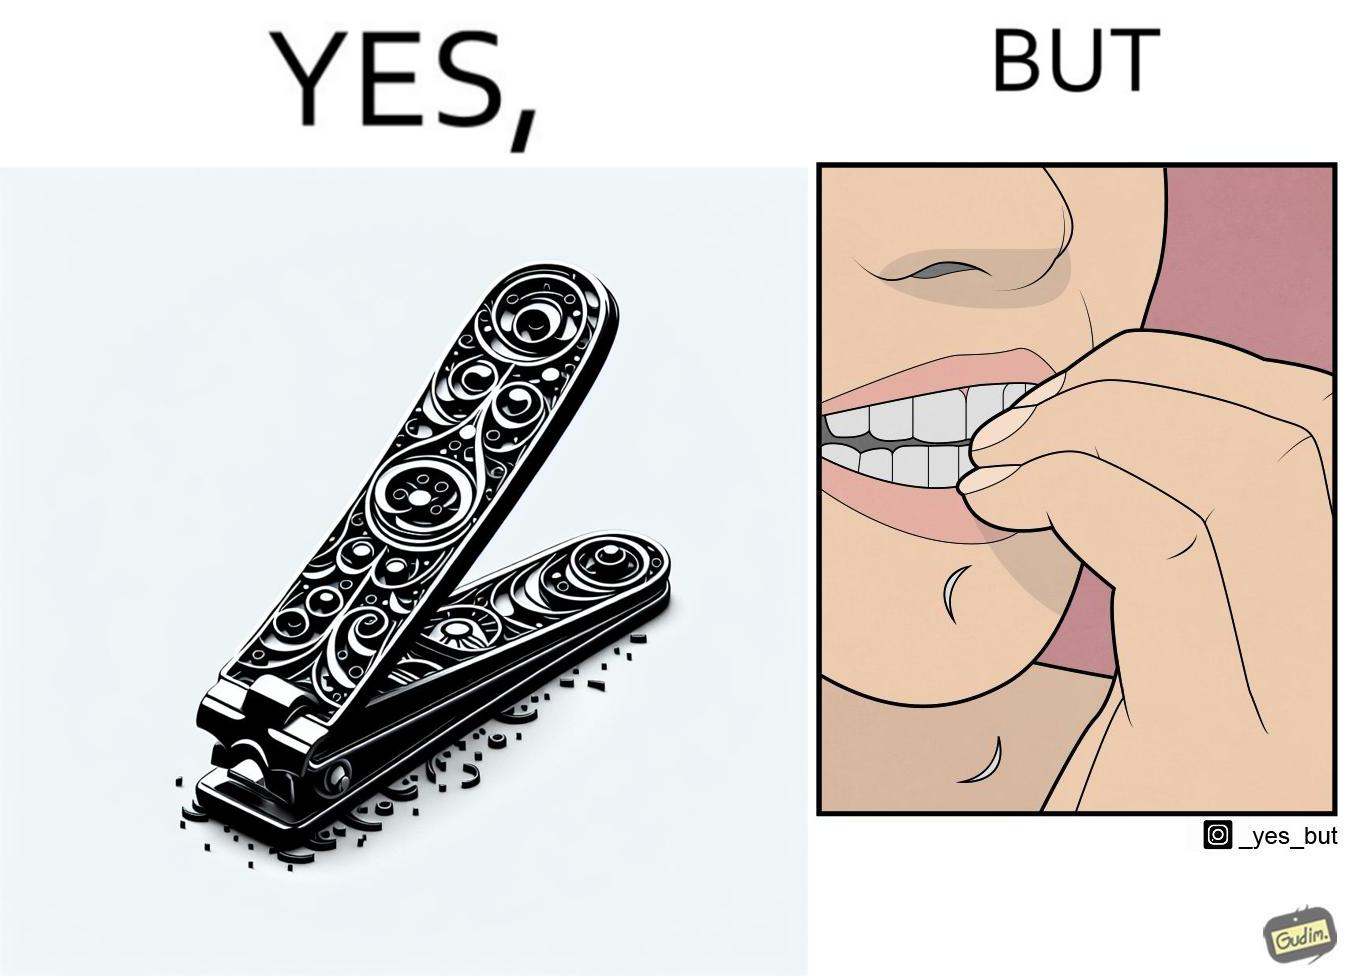What does this image depict? The image is ironic, because even after nail clippers are available people prefer biting their nails by teeth 